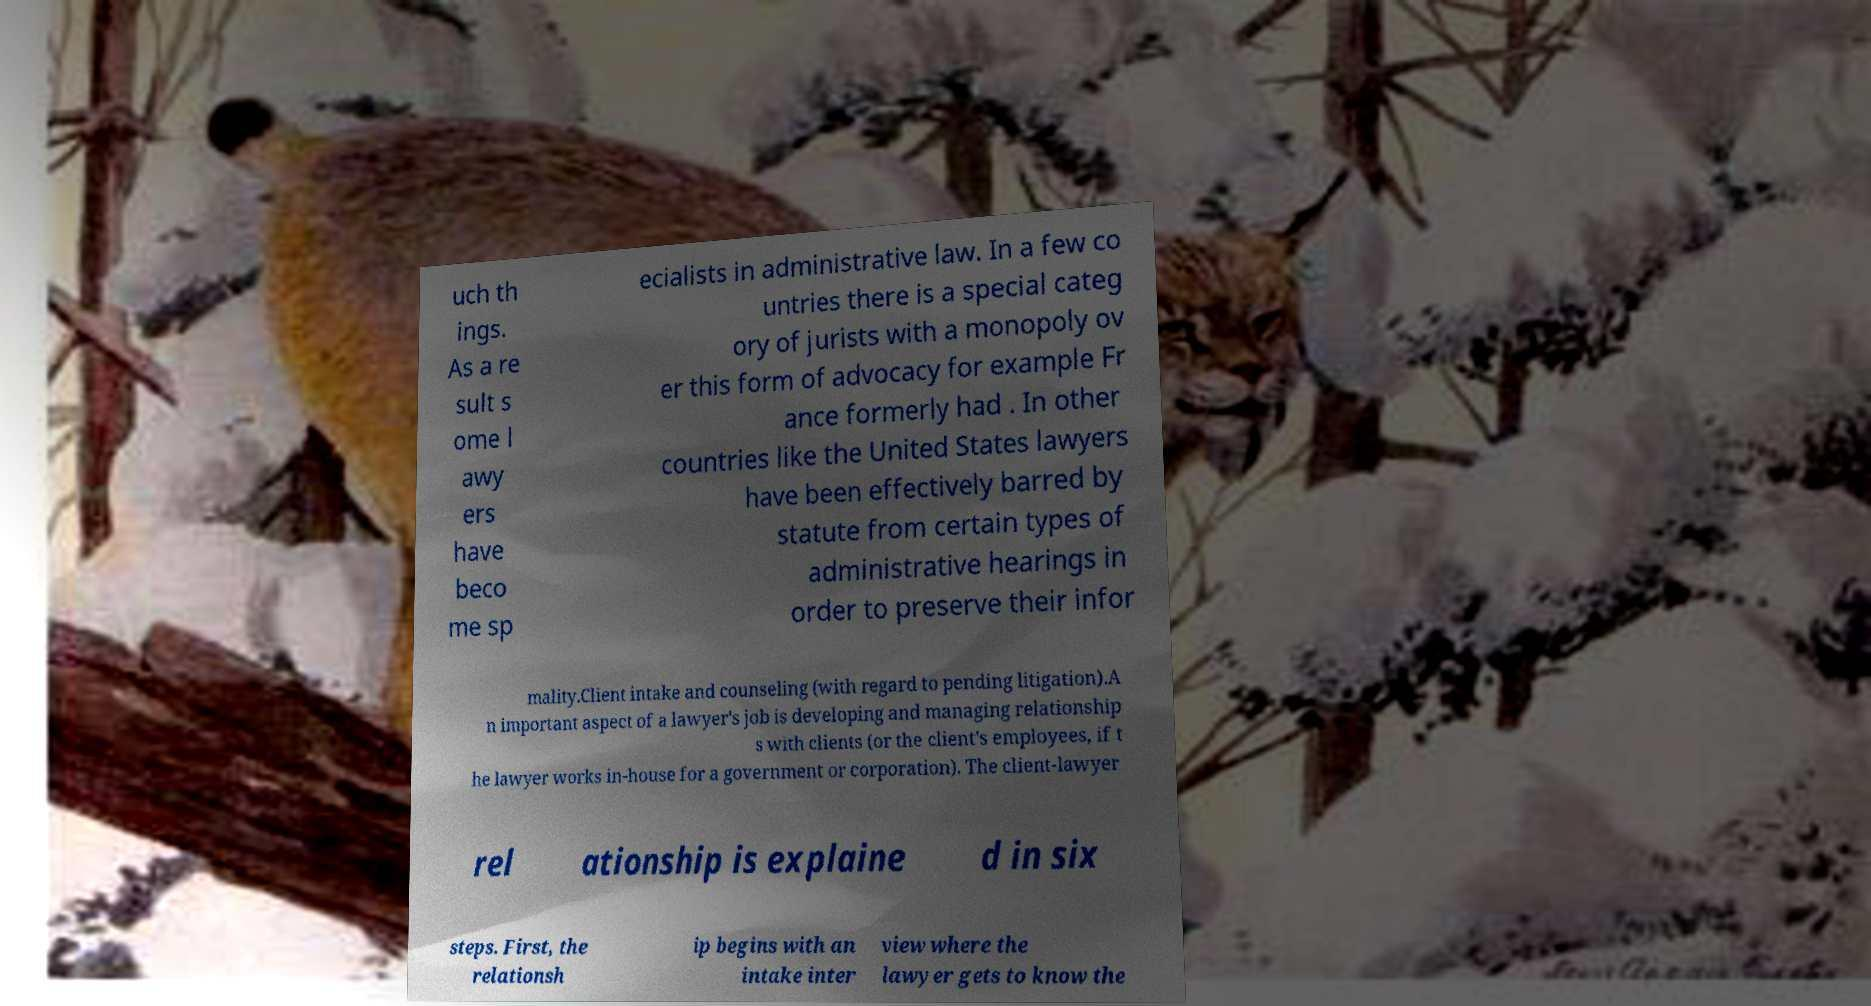Can you read and provide the text displayed in the image?This photo seems to have some interesting text. Can you extract and type it out for me? uch th ings. As a re sult s ome l awy ers have beco me sp ecialists in administrative law. In a few co untries there is a special categ ory of jurists with a monopoly ov er this form of advocacy for example Fr ance formerly had . In other countries like the United States lawyers have been effectively barred by statute from certain types of administrative hearings in order to preserve their infor mality.Client intake and counseling (with regard to pending litigation).A n important aspect of a lawyer's job is developing and managing relationship s with clients (or the client's employees, if t he lawyer works in-house for a government or corporation). The client-lawyer rel ationship is explaine d in six steps. First, the relationsh ip begins with an intake inter view where the lawyer gets to know the 